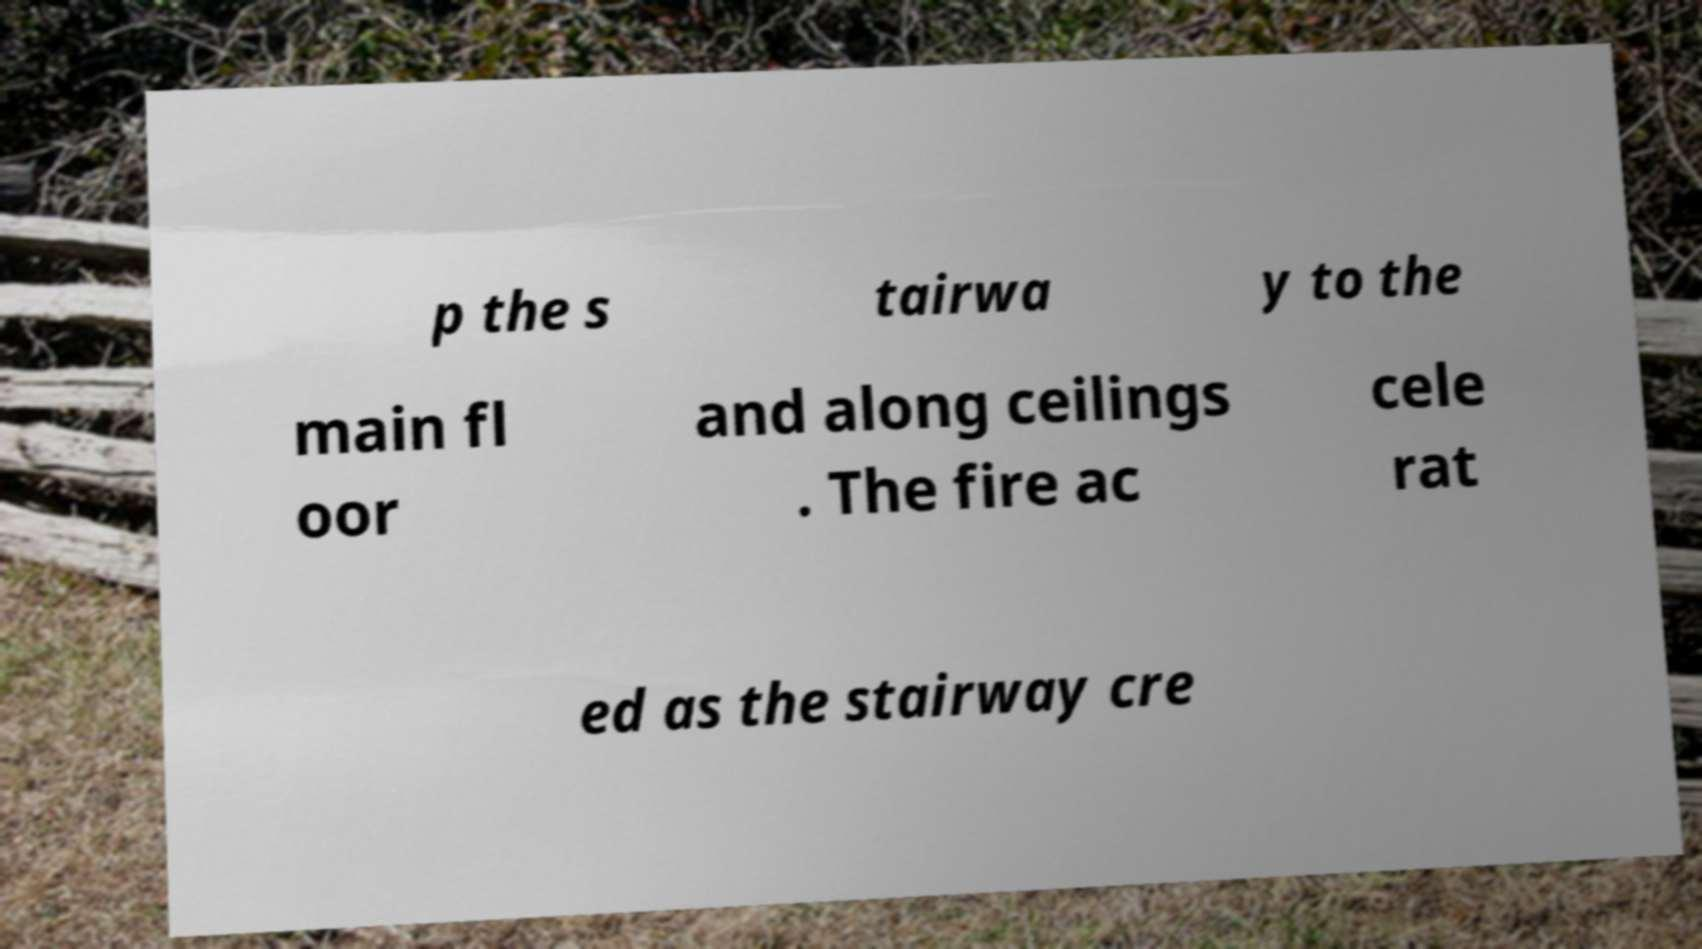For documentation purposes, I need the text within this image transcribed. Could you provide that? p the s tairwa y to the main fl oor and along ceilings . The fire ac cele rat ed as the stairway cre 